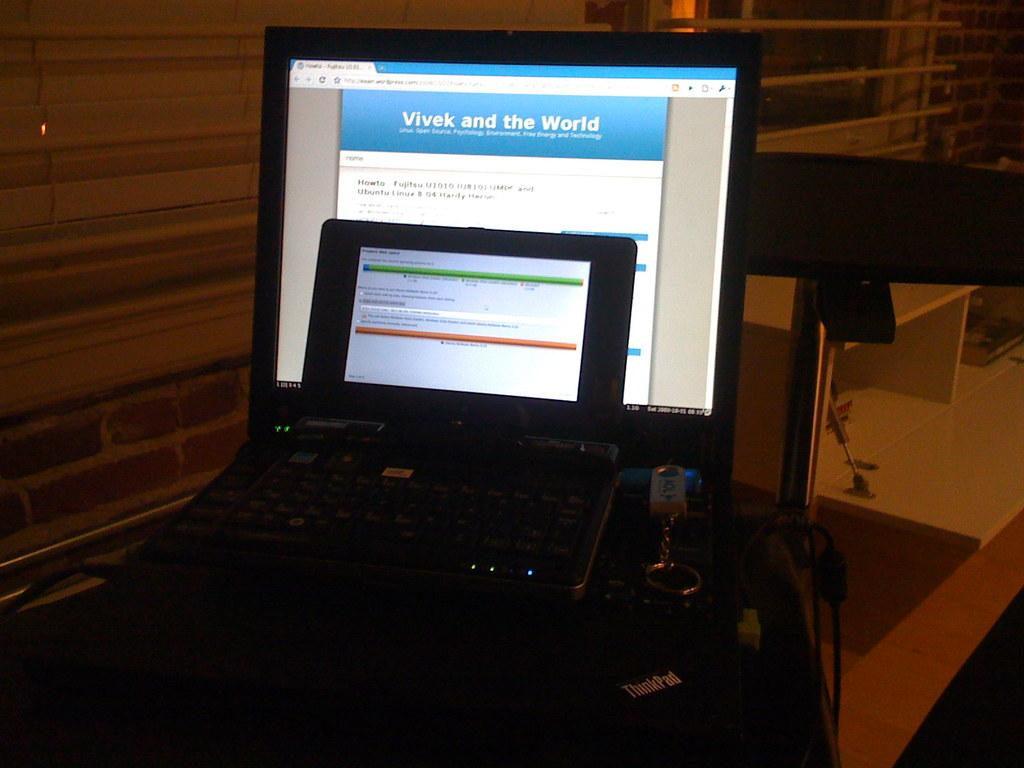<image>
Provide a brief description of the given image. A computer screen with a web page opened that is titled Vivek and the World. 